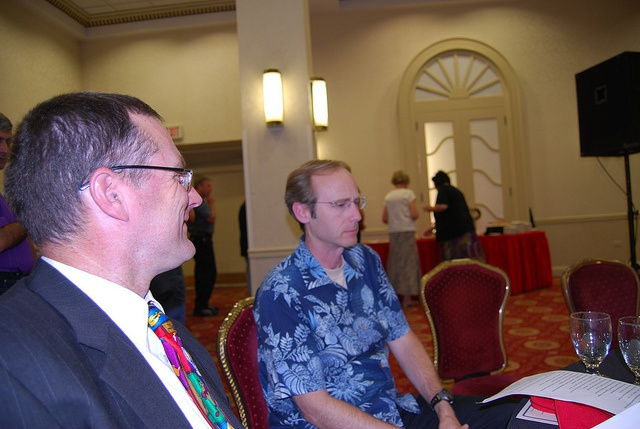Describe the objects in this image and their specific colors. I can see people in black, navy, purple, and pink tones, people in black, navy, gray, and lightpink tones, chair in black, maroon, olive, and gray tones, dining table in black, maroon, and brown tones, and chair in black, maroon, olive, and navy tones in this image. 